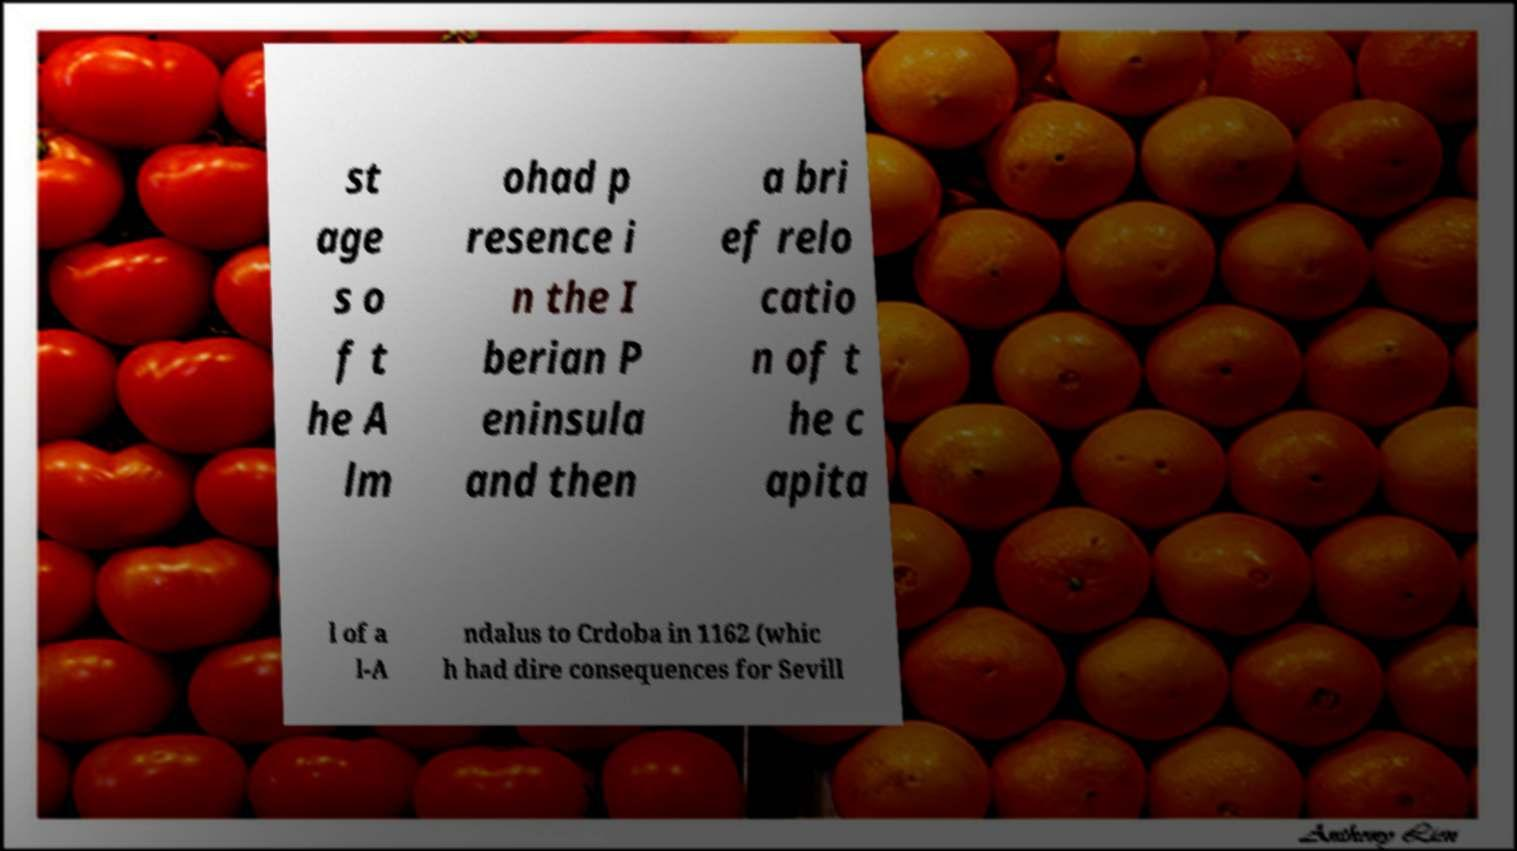For documentation purposes, I need the text within this image transcribed. Could you provide that? st age s o f t he A lm ohad p resence i n the I berian P eninsula and then a bri ef relo catio n of t he c apita l of a l-A ndalus to Crdoba in 1162 (whic h had dire consequences for Sevill 